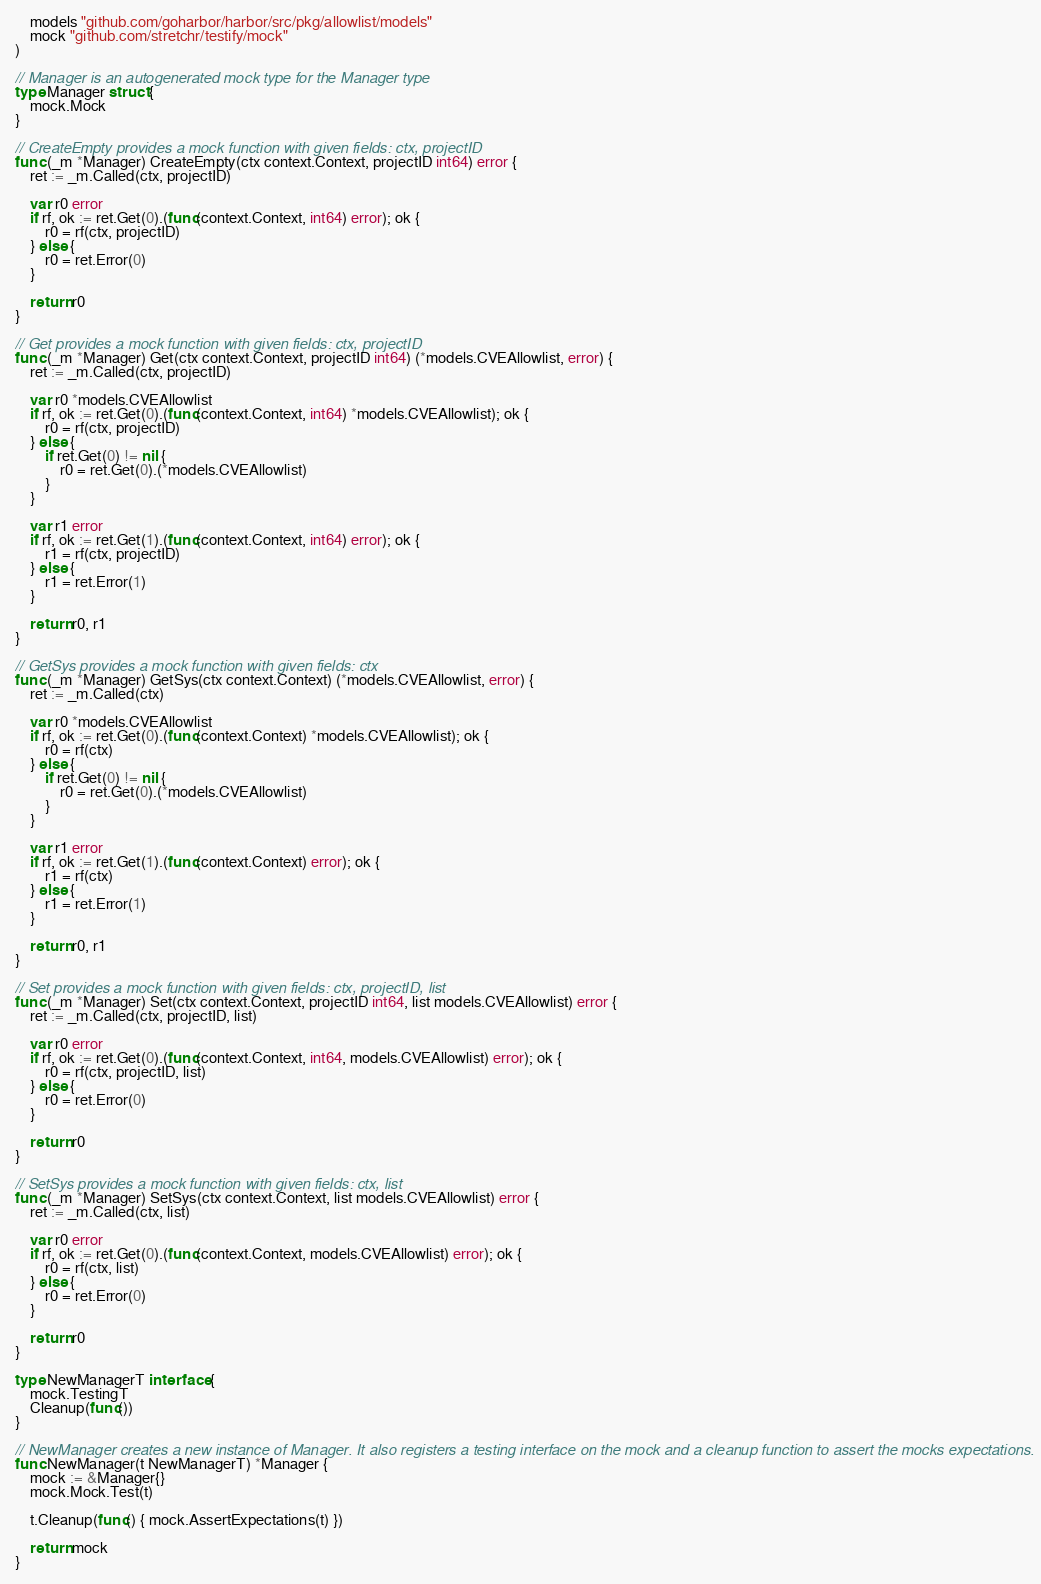Convert code to text. <code><loc_0><loc_0><loc_500><loc_500><_Go_>
	models "github.com/goharbor/harbor/src/pkg/allowlist/models"
	mock "github.com/stretchr/testify/mock"
)

// Manager is an autogenerated mock type for the Manager type
type Manager struct {
	mock.Mock
}

// CreateEmpty provides a mock function with given fields: ctx, projectID
func (_m *Manager) CreateEmpty(ctx context.Context, projectID int64) error {
	ret := _m.Called(ctx, projectID)

	var r0 error
	if rf, ok := ret.Get(0).(func(context.Context, int64) error); ok {
		r0 = rf(ctx, projectID)
	} else {
		r0 = ret.Error(0)
	}

	return r0
}

// Get provides a mock function with given fields: ctx, projectID
func (_m *Manager) Get(ctx context.Context, projectID int64) (*models.CVEAllowlist, error) {
	ret := _m.Called(ctx, projectID)

	var r0 *models.CVEAllowlist
	if rf, ok := ret.Get(0).(func(context.Context, int64) *models.CVEAllowlist); ok {
		r0 = rf(ctx, projectID)
	} else {
		if ret.Get(0) != nil {
			r0 = ret.Get(0).(*models.CVEAllowlist)
		}
	}

	var r1 error
	if rf, ok := ret.Get(1).(func(context.Context, int64) error); ok {
		r1 = rf(ctx, projectID)
	} else {
		r1 = ret.Error(1)
	}

	return r0, r1
}

// GetSys provides a mock function with given fields: ctx
func (_m *Manager) GetSys(ctx context.Context) (*models.CVEAllowlist, error) {
	ret := _m.Called(ctx)

	var r0 *models.CVEAllowlist
	if rf, ok := ret.Get(0).(func(context.Context) *models.CVEAllowlist); ok {
		r0 = rf(ctx)
	} else {
		if ret.Get(0) != nil {
			r0 = ret.Get(0).(*models.CVEAllowlist)
		}
	}

	var r1 error
	if rf, ok := ret.Get(1).(func(context.Context) error); ok {
		r1 = rf(ctx)
	} else {
		r1 = ret.Error(1)
	}

	return r0, r1
}

// Set provides a mock function with given fields: ctx, projectID, list
func (_m *Manager) Set(ctx context.Context, projectID int64, list models.CVEAllowlist) error {
	ret := _m.Called(ctx, projectID, list)

	var r0 error
	if rf, ok := ret.Get(0).(func(context.Context, int64, models.CVEAllowlist) error); ok {
		r0 = rf(ctx, projectID, list)
	} else {
		r0 = ret.Error(0)
	}

	return r0
}

// SetSys provides a mock function with given fields: ctx, list
func (_m *Manager) SetSys(ctx context.Context, list models.CVEAllowlist) error {
	ret := _m.Called(ctx, list)

	var r0 error
	if rf, ok := ret.Get(0).(func(context.Context, models.CVEAllowlist) error); ok {
		r0 = rf(ctx, list)
	} else {
		r0 = ret.Error(0)
	}

	return r0
}

type NewManagerT interface {
	mock.TestingT
	Cleanup(func())
}

// NewManager creates a new instance of Manager. It also registers a testing interface on the mock and a cleanup function to assert the mocks expectations.
func NewManager(t NewManagerT) *Manager {
	mock := &Manager{}
	mock.Mock.Test(t)

	t.Cleanup(func() { mock.AssertExpectations(t) })

	return mock
}
</code> 